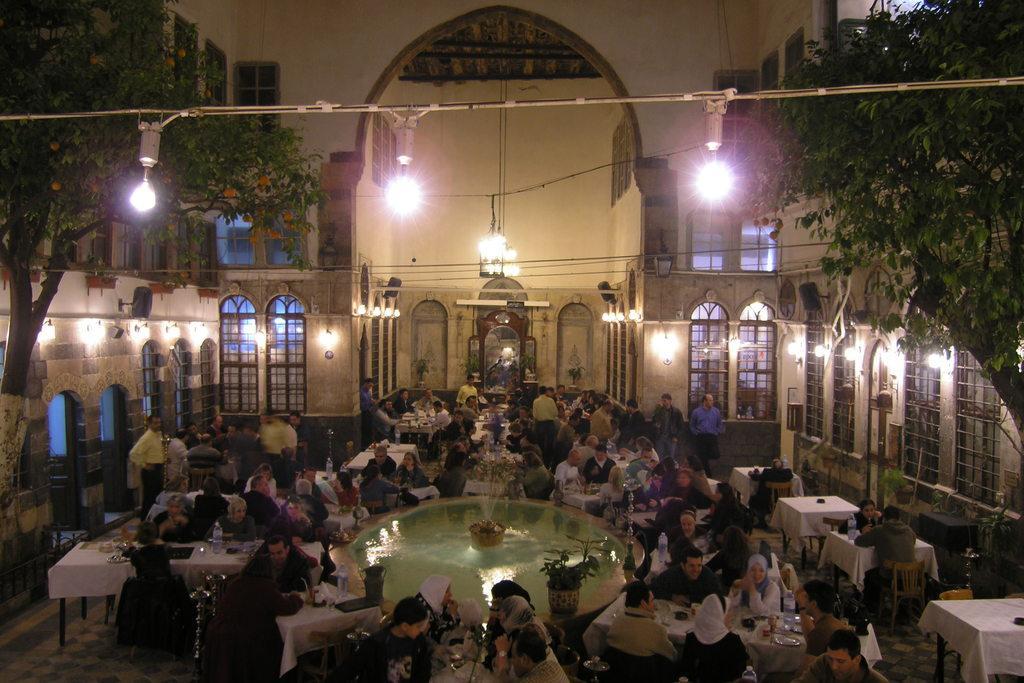Please provide a concise description of this image. In the picture we can see inside the building with people sitting on the chairs near the tables and having their meals and in the middle of them we can see a fountain and on the either sides we can see walls with windows and glasses to it and two trees on either sides and three lights to the wire and in the background we can see building entrance with door and to the ceiling of it we can see some lights are hanged. 